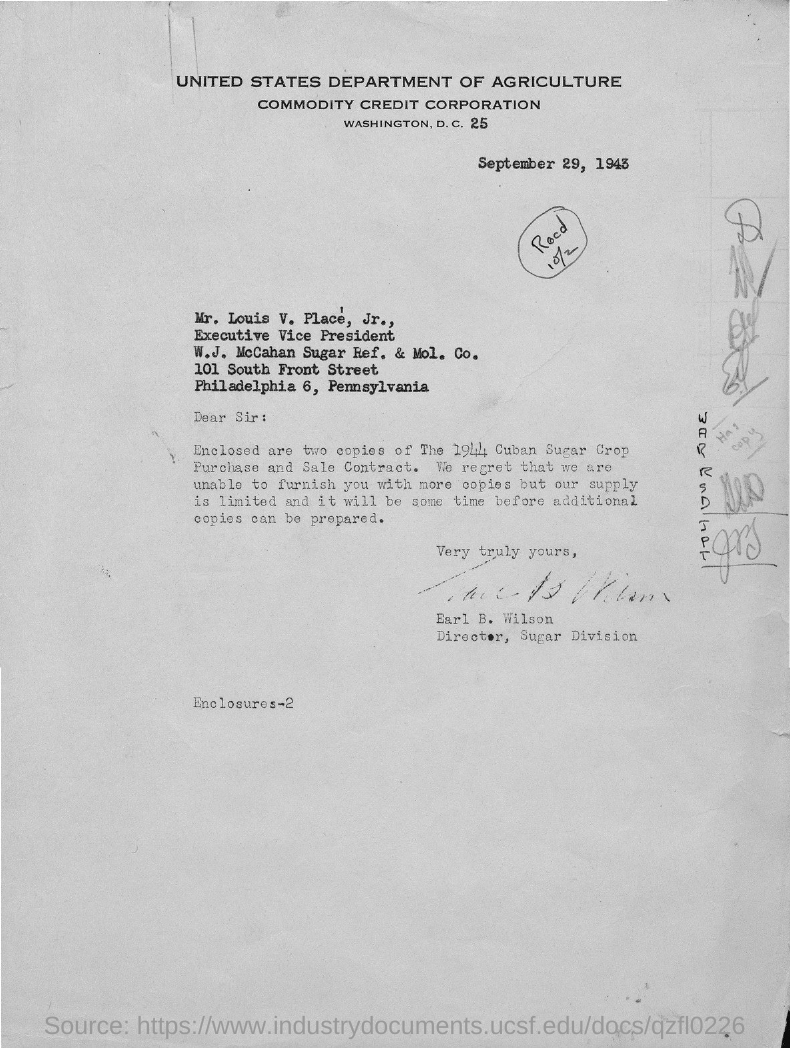Point out several critical features in this image. The addressee of this letter is Mr. Louis V. Place Jr. Louis V. Place Jr. holds the designation of Executive Vice President. The issued date of this letter is September 29, 1943. The sender of this letter is Earl B. Wilson. 